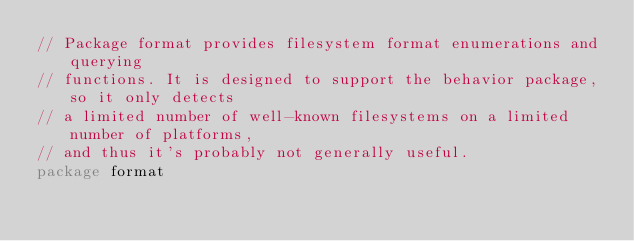Convert code to text. <code><loc_0><loc_0><loc_500><loc_500><_Go_>// Package format provides filesystem format enumerations and querying
// functions. It is designed to support the behavior package, so it only detects
// a limited number of well-known filesystems on a limited number of platforms,
// and thus it's probably not generally useful.
package format
</code> 